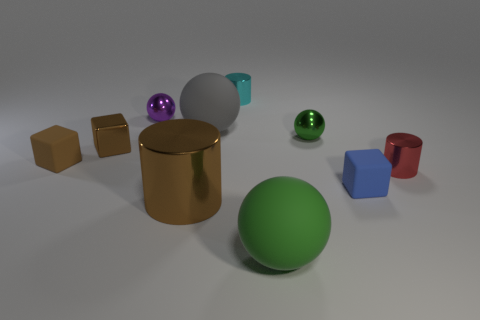Subtract all brown cylinders. How many cylinders are left? 2 Subtract all blue blocks. How many blocks are left? 2 Subtract all red cylinders. How many gray spheres are left? 1 Subtract all cylinders. How many objects are left? 7 Subtract 1 cylinders. How many cylinders are left? 2 Subtract all large yellow shiny balls. Subtract all big brown things. How many objects are left? 9 Add 6 small green metallic objects. How many small green metallic objects are left? 7 Add 1 tiny green spheres. How many tiny green spheres exist? 2 Subtract 0 red balls. How many objects are left? 10 Subtract all yellow cylinders. Subtract all purple balls. How many cylinders are left? 3 